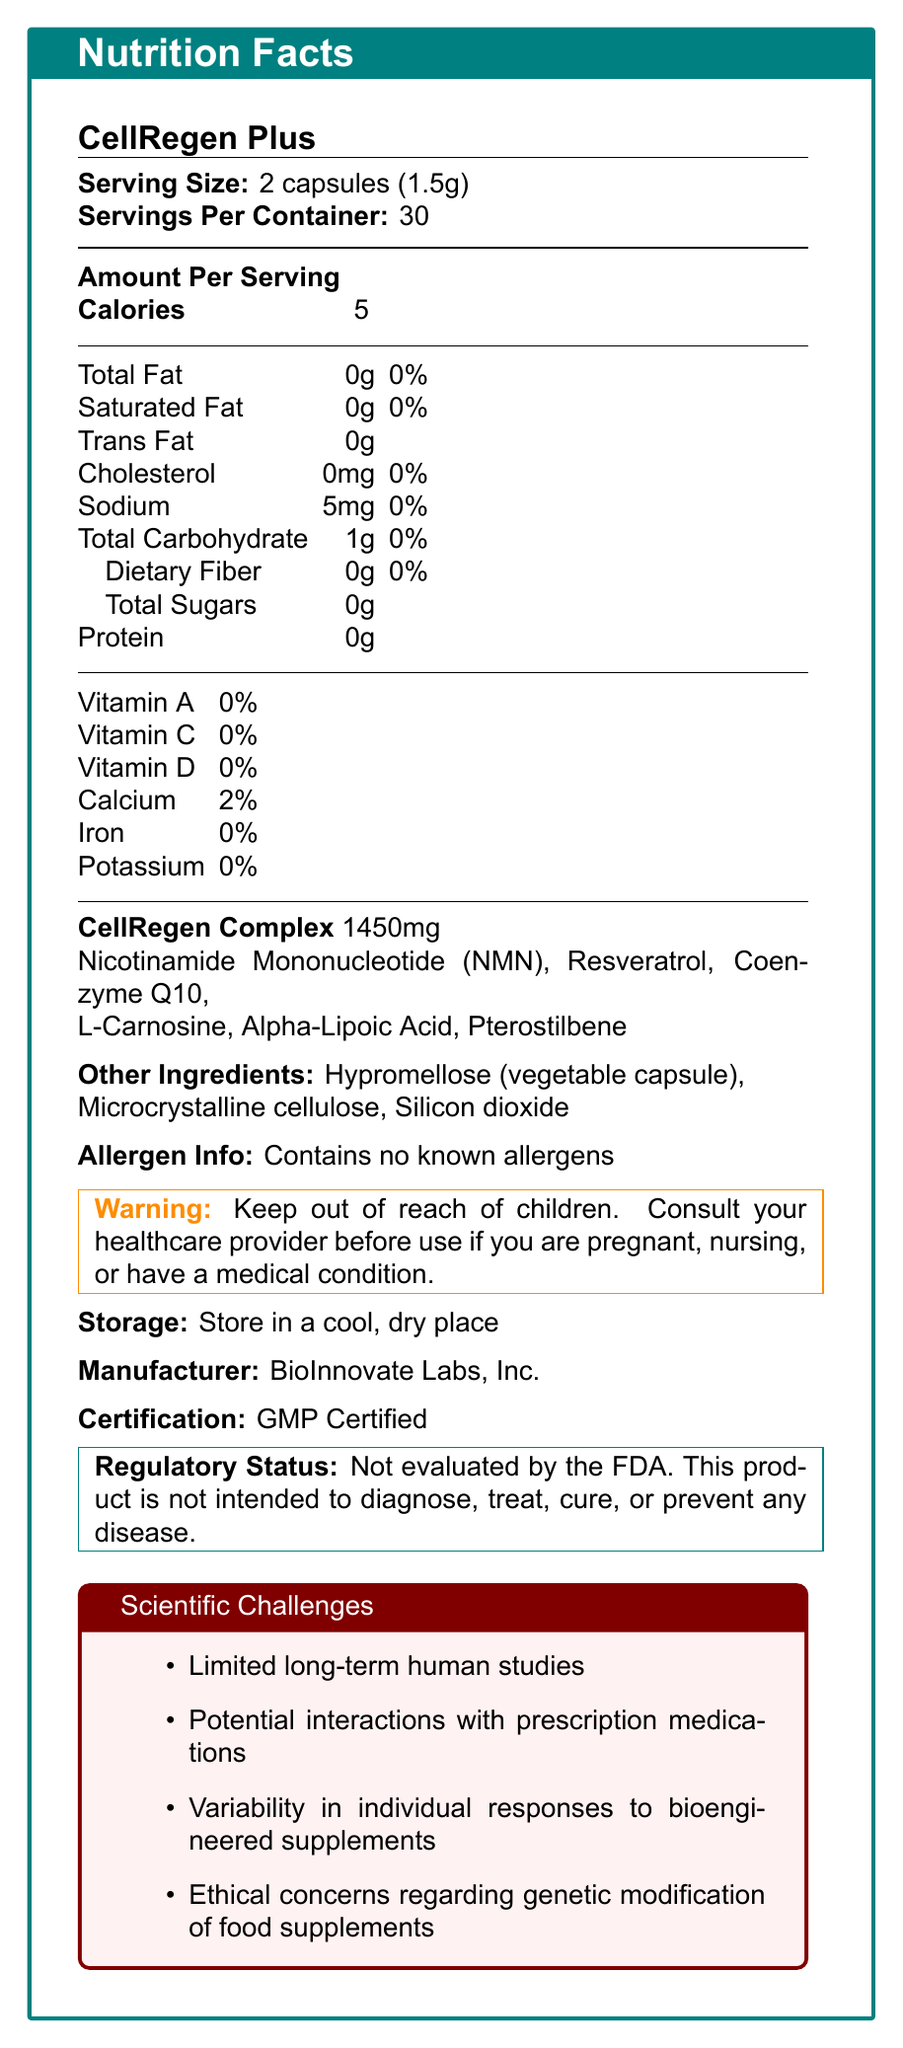what is the serving size for CellRegen Plus? The document states the serving size as "2 capsules (1.5g)".
Answer: 2 capsules (1.5g) how many calories are there per serving? The document specifies that there are 5 calories per serving.
Answer: 5 Are there any allergens in CellRegen Plus? The document mentions that it contains no known allergens.
Answer: No what is the proprietary blend called and how much does it weigh? The document lists a proprietary blend named "CellRegen Complex" which weighs 1450mg.
Answer: CellRegen Complex, 1450mg how many servings are in each container of CellRegen Plus? The document states that there are 30 servings per container.
Answer: 30 which of the following is not an ingredient in CellRegen Complex? A. Nicotinamide Mononucleotide (NMN) B. Coenzyme Q10 C. Microcrystalline cellulose D. Resveratrol Microcrystalline cellulose is listed as one of the other ingredients, not part of the CellRegen Complex proprietary blend.
Answer: C what is the amount of sodium per serving? The document specifies that there are 5mg of sodium per serving.
Answer: 5mg what percentage of the daily value of calcium does CellRegen Plus provide per serving? The document mentions that there is 2% of the daily value of calcium per serving.
Answer: 2% Is CellRegen Plus FDA approved? The document clearly states that this product is not evaluated by the FDA.
Answer: No which ingredient in the proprietary blend is commonly associated with anti-aging benefits? A. Alpha-Lipoic Acid B. Silicon dioxide C. Hypromellose D. Microcrystalline cellulose Alpha-Lipoic Acid is often associated with anti-aging benefits, and it is listed as one of the ingredients in the CellRegen Complex.
Answer: A Does CellRegen Plus contain any sugar? The document lists total sugars as 0g per serving.
Answer: No Is there any fiber in CellRegen Plus? The document mentions 0g of dietary fiber.
Answer: No Summarize the main nutritional and functional components of CellRegen Plus. The document provides details such as the serving size, caloric content, lack of allergens, and a proprietary blend that includes several bioengineered ingredients. It highlights the functional claims, nutritional content, and regulatory status, summarizing its main features and marketed benefits.
Answer: CellRegen Plus is a bioengineered food supplement designed to enhance cellular regeneration with a proprietary blend called CellRegen Complex, which includes ingredients like Nicotinamide Mononucleotide (NMN), Resveratrol, and Coenzyme Q10. It contains no fat, cholesterol, fiber, or sugars, and contributes 5 calories per serving. It's marketed with claims like enhanced mitochondrial function and improved DNA repair mechanisms, though not evaluated by the FDA. How does CellRegen Plus support cellular functions, according to the document? The document lists these claims under its controversial claims section, suggesting mechanisms by which the supplement supports cellular functions.
Answer: Enhanced mitochondrial function, improved DNA repair mechanisms, accelerated cellular regeneration, increased NAD+ levels what potential challenges are associated with CellRegen Plus? The document lists these points under the scientific challenges section.
Answer: Limited long-term human studies, potential interactions with prescription medications, variability in individual responses, ethical concerns regarding genetic modification What is the storage recommendation for CellRegen Plus? The document clearly states the storage recommendation.
Answer: Store in a cool, dry place where is CellRegen Plus manufactured? The document states that BioInnovate Labs, Inc. is the manufacturer.
Answer: BioInnovate Labs, Inc. which certification does CellRegen Plus have? The document mentions that the product is GMP Certified.
Answer: GMP Certified What interactions with prescription medications should be considered when taking CellRegen Plus? The document mentions potential interactions with prescription medications as a scientific challenge but does not specify what these interactions might be.
Answer: Not enough information What is the total carbohydrate content per serving? The document lists the total carbohydrate content per serving as 1g.
Answer: 1g 